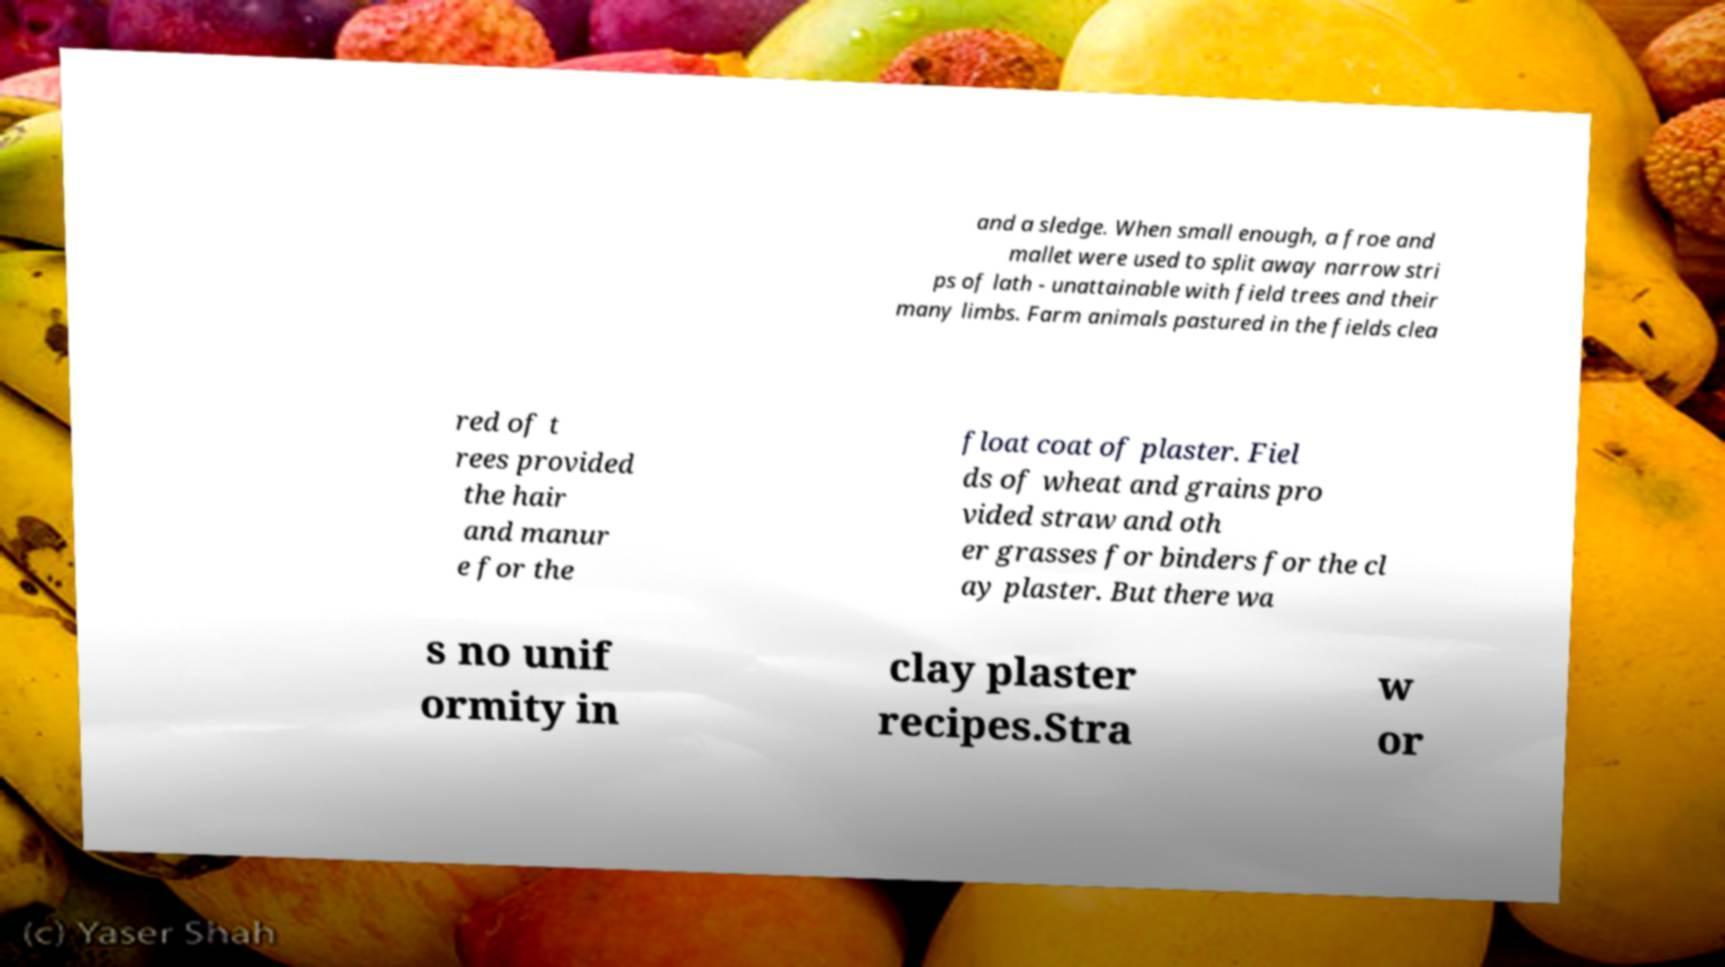Please read and relay the text visible in this image. What does it say? and a sledge. When small enough, a froe and mallet were used to split away narrow stri ps of lath - unattainable with field trees and their many limbs. Farm animals pastured in the fields clea red of t rees provided the hair and manur e for the float coat of plaster. Fiel ds of wheat and grains pro vided straw and oth er grasses for binders for the cl ay plaster. But there wa s no unif ormity in clay plaster recipes.Stra w or 